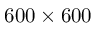Convert formula to latex. <formula><loc_0><loc_0><loc_500><loc_500>6 0 0 \times 6 0 0</formula> 